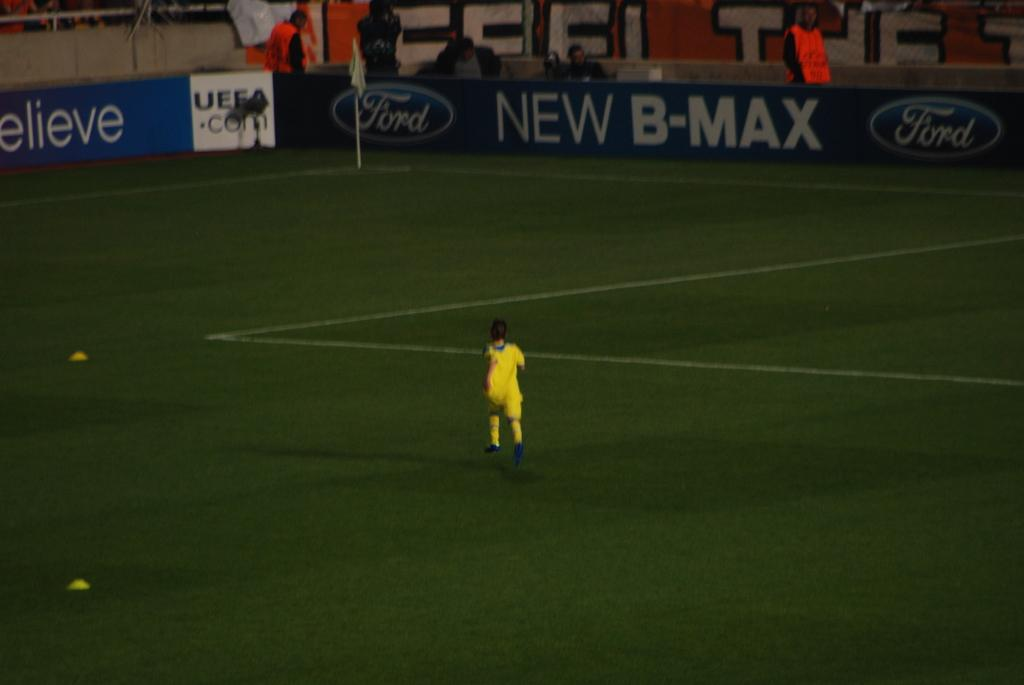<image>
Give a short and clear explanation of the subsequent image. A sign for New B-Max is near the corner of a soccer field. 